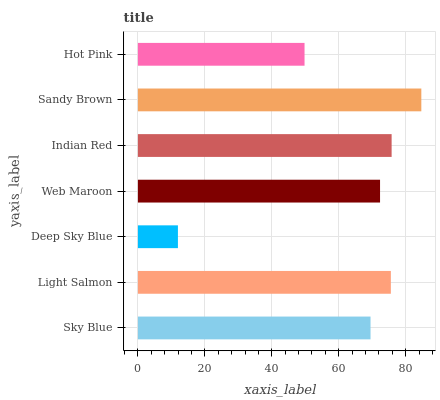Is Deep Sky Blue the minimum?
Answer yes or no. Yes. Is Sandy Brown the maximum?
Answer yes or no. Yes. Is Light Salmon the minimum?
Answer yes or no. No. Is Light Salmon the maximum?
Answer yes or no. No. Is Light Salmon greater than Sky Blue?
Answer yes or no. Yes. Is Sky Blue less than Light Salmon?
Answer yes or no. Yes. Is Sky Blue greater than Light Salmon?
Answer yes or no. No. Is Light Salmon less than Sky Blue?
Answer yes or no. No. Is Web Maroon the high median?
Answer yes or no. Yes. Is Web Maroon the low median?
Answer yes or no. Yes. Is Sandy Brown the high median?
Answer yes or no. No. Is Sandy Brown the low median?
Answer yes or no. No. 